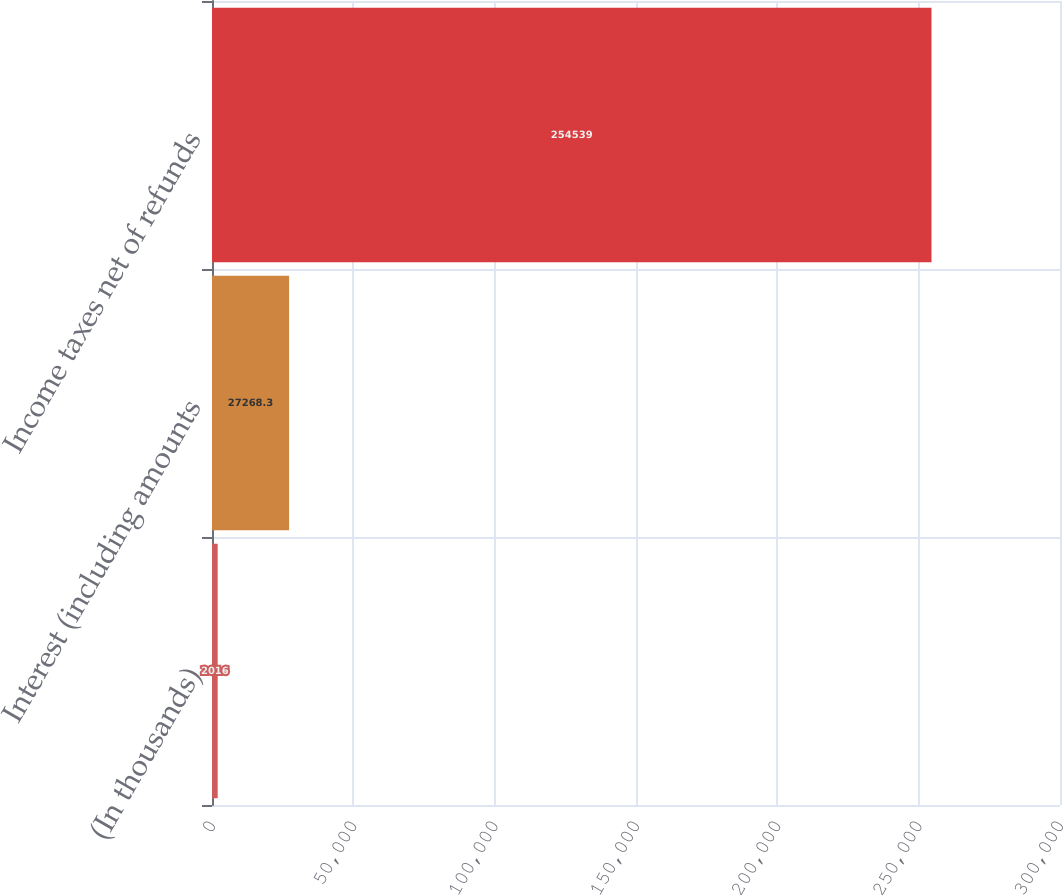Convert chart to OTSL. <chart><loc_0><loc_0><loc_500><loc_500><bar_chart><fcel>(In thousands)<fcel>Interest (including amounts<fcel>Income taxes net of refunds<nl><fcel>2016<fcel>27268.3<fcel>254539<nl></chart> 